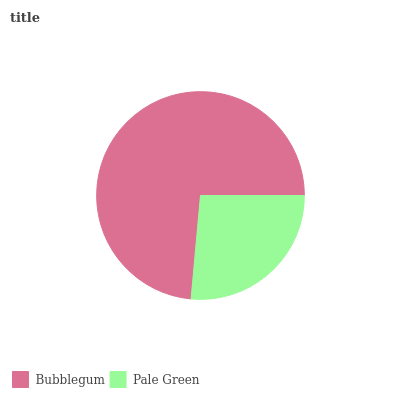Is Pale Green the minimum?
Answer yes or no. Yes. Is Bubblegum the maximum?
Answer yes or no. Yes. Is Pale Green the maximum?
Answer yes or no. No. Is Bubblegum greater than Pale Green?
Answer yes or no. Yes. Is Pale Green less than Bubblegum?
Answer yes or no. Yes. Is Pale Green greater than Bubblegum?
Answer yes or no. No. Is Bubblegum less than Pale Green?
Answer yes or no. No. Is Bubblegum the high median?
Answer yes or no. Yes. Is Pale Green the low median?
Answer yes or no. Yes. Is Pale Green the high median?
Answer yes or no. No. Is Bubblegum the low median?
Answer yes or no. No. 